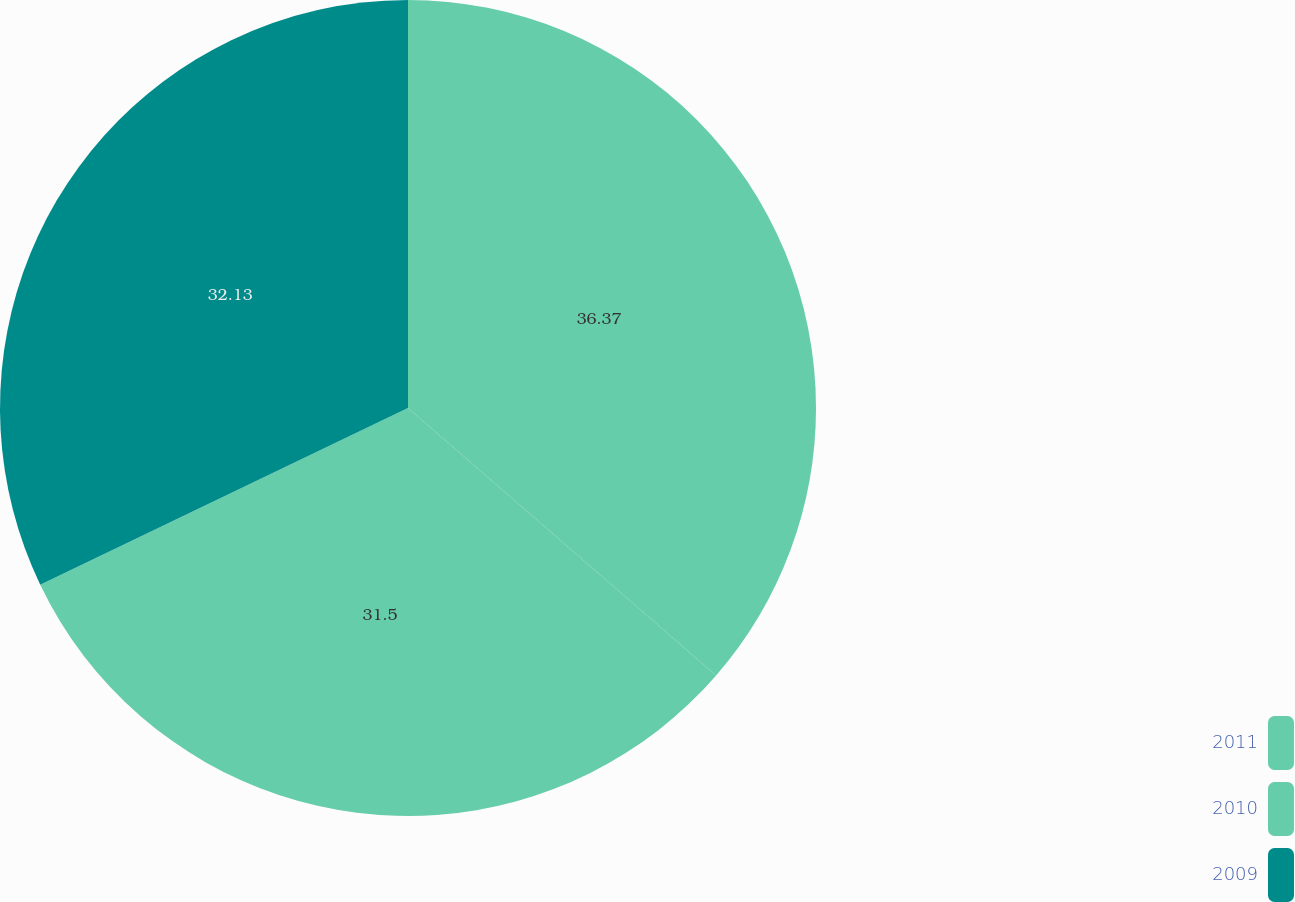<chart> <loc_0><loc_0><loc_500><loc_500><pie_chart><fcel>2011<fcel>2010<fcel>2009<nl><fcel>36.38%<fcel>31.5%<fcel>32.13%<nl></chart> 